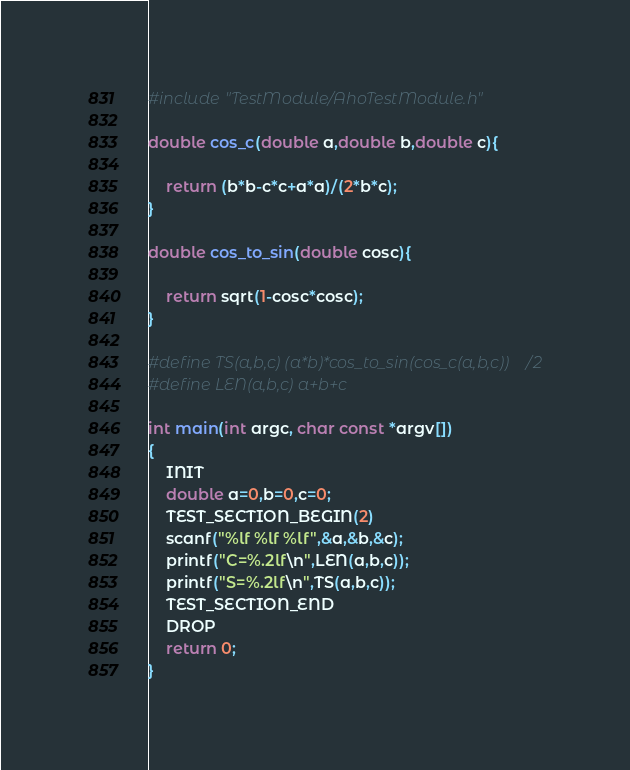Convert code to text. <code><loc_0><loc_0><loc_500><loc_500><_C_>#include "TestModule/AhoTestModule.h"

double cos_c(double a,double b,double c){

    return (b*b-c*c+a*a)/(2*b*c);
}

double cos_to_sin(double cosc){

    return sqrt(1-cosc*cosc);
}

#define TS(a,b,c) (a*b)*cos_to_sin(cos_c(a,b,c))/2
#define LEN(a,b,c) a+b+c

int main(int argc, char const *argv[])
{
    INIT
    double a=0,b=0,c=0;
    TEST_SECTION_BEGIN(2)
    scanf("%lf %lf %lf",&a,&b,&c);
    printf("C=%.2lf\n",LEN(a,b,c));
    printf("S=%.2lf\n",TS(a,b,c));
    TEST_SECTION_END
    DROP
    return 0;
}
</code> 